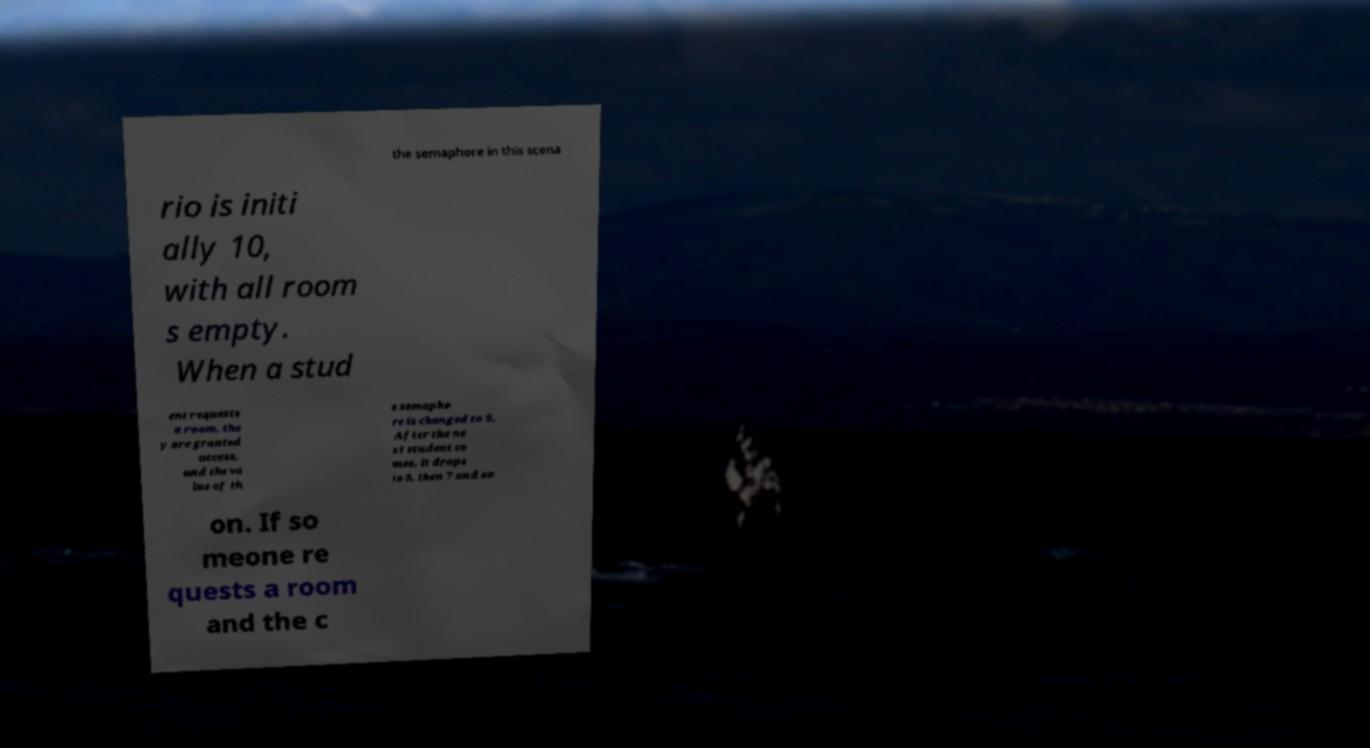Could you assist in decoding the text presented in this image and type it out clearly? the semaphore in this scena rio is initi ally 10, with all room s empty. When a stud ent requests a room, the y are granted access, and the va lue of th e semapho re is changed to 9. After the ne xt student co mes, it drops to 8, then 7 and so on. If so meone re quests a room and the c 